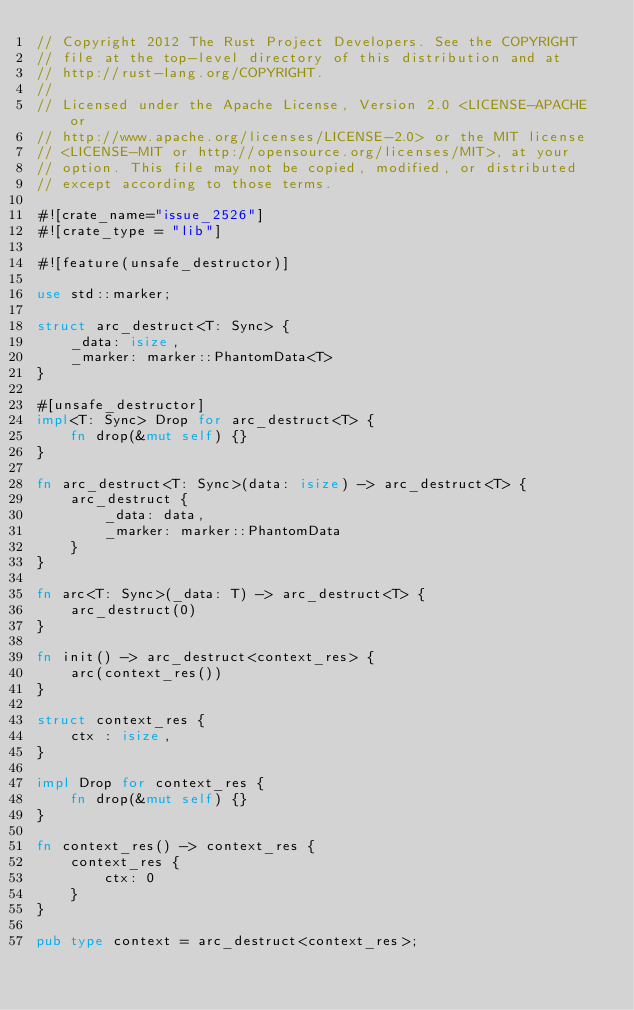Convert code to text. <code><loc_0><loc_0><loc_500><loc_500><_Rust_>// Copyright 2012 The Rust Project Developers. See the COPYRIGHT
// file at the top-level directory of this distribution and at
// http://rust-lang.org/COPYRIGHT.
//
// Licensed under the Apache License, Version 2.0 <LICENSE-APACHE or
// http://www.apache.org/licenses/LICENSE-2.0> or the MIT license
// <LICENSE-MIT or http://opensource.org/licenses/MIT>, at your
// option. This file may not be copied, modified, or distributed
// except according to those terms.

#![crate_name="issue_2526"]
#![crate_type = "lib"]

#![feature(unsafe_destructor)]

use std::marker;

struct arc_destruct<T: Sync> {
    _data: isize,
    _marker: marker::PhantomData<T>
}

#[unsafe_destructor]
impl<T: Sync> Drop for arc_destruct<T> {
    fn drop(&mut self) {}
}

fn arc_destruct<T: Sync>(data: isize) -> arc_destruct<T> {
    arc_destruct {
        _data: data,
        _marker: marker::PhantomData
    }
}

fn arc<T: Sync>(_data: T) -> arc_destruct<T> {
    arc_destruct(0)
}

fn init() -> arc_destruct<context_res> {
    arc(context_res())
}

struct context_res {
    ctx : isize,
}

impl Drop for context_res {
    fn drop(&mut self) {}
}

fn context_res() -> context_res {
    context_res {
        ctx: 0
    }
}

pub type context = arc_destruct<context_res>;
</code> 